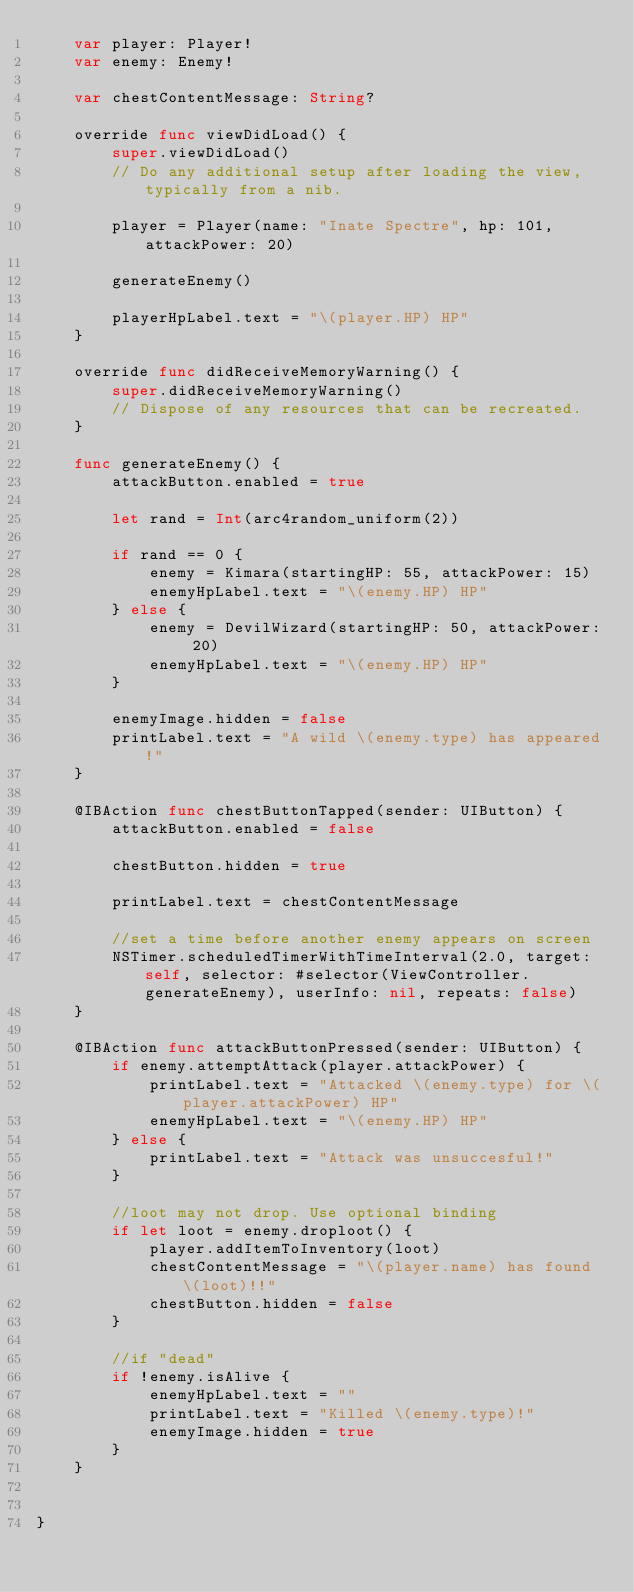Convert code to text. <code><loc_0><loc_0><loc_500><loc_500><_Swift_>    var player: Player!
    var enemy: Enemy!
    
    var chestContentMessage: String?
    
    override func viewDidLoad() {
        super.viewDidLoad()
        // Do any additional setup after loading the view, typically from a nib.
        
        player = Player(name: "Inate Spectre", hp: 101, attackPower: 20)
        
        generateEnemy()
        
        playerHpLabel.text = "\(player.HP) HP"
    }

    override func didReceiveMemoryWarning() {
        super.didReceiveMemoryWarning()
        // Dispose of any resources that can be recreated.
    }
    
    func generateEnemy() {
        attackButton.enabled = true
        
        let rand = Int(arc4random_uniform(2))
        
        if rand == 0 {
            enemy = Kimara(startingHP: 55, attackPower: 15)
            enemyHpLabel.text = "\(enemy.HP) HP"
        } else {
            enemy = DevilWizard(startingHP: 50, attackPower: 20)
            enemyHpLabel.text = "\(enemy.HP) HP"
        }
        
        enemyImage.hidden = false
        printLabel.text = "A wild \(enemy.type) has appeared!"
    }

    @IBAction func chestButtonTapped(sender: UIButton) {
        attackButton.enabled = false
        
        chestButton.hidden = true
        
        printLabel.text = chestContentMessage
        
        //set a time before another enemy appears on screen
        NSTimer.scheduledTimerWithTimeInterval(2.0, target: self, selector: #selector(ViewController.generateEnemy), userInfo: nil, repeats: false)
    }
    
    @IBAction func attackButtonPressed(sender: UIButton) {
        if enemy.attemptAttack(player.attackPower) {
            printLabel.text = "Attacked \(enemy.type) for \(player.attackPower) HP"
            enemyHpLabel.text = "\(enemy.HP) HP"
        } else {
            printLabel.text = "Attack was unsuccesful!"
        }
        
        //loot may not drop. Use optional binding
        if let loot = enemy.droploot() {
            player.addItemToInventory(loot)
            chestContentMessage = "\(player.name) has found \(loot)!!"
            chestButton.hidden = false
        }
        
        //if "dead"
        if !enemy.isAlive {
            enemyHpLabel.text = ""
            printLabel.text = "Killed \(enemy.type)!"
            enemyImage.hidden = true
        }
    }
    

}

</code> 